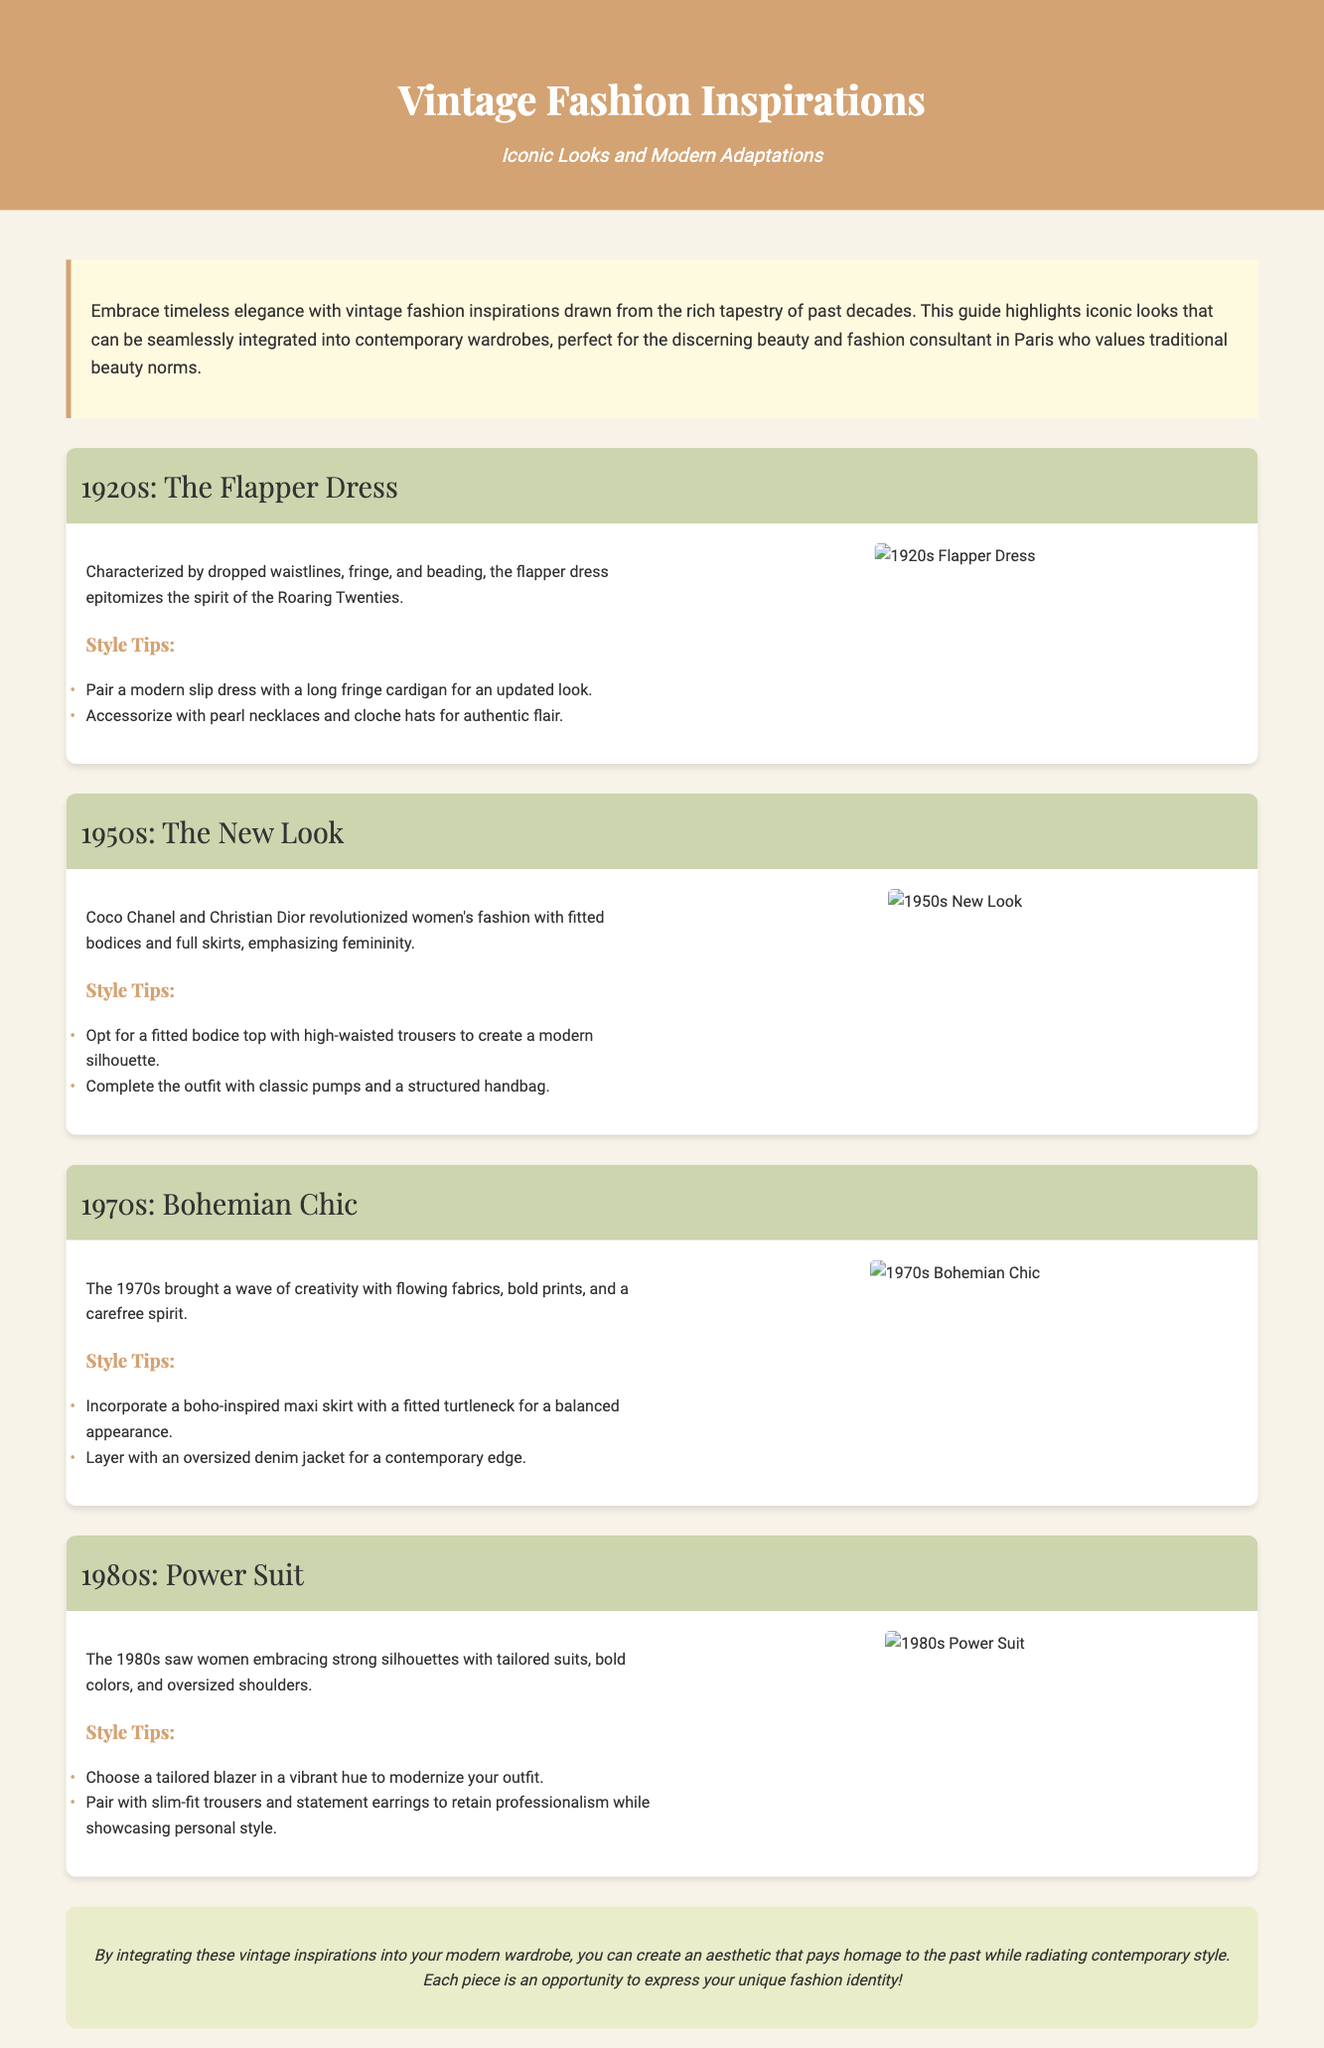What decade is characterized by the Flapper Dress? The document states that the Flapper Dress is an iconic look from the 1920s.
Answer: 1920s What fashion element is typical of the 1950s New Look? The document highlights fitted bodices and full skirts as key elements of the New Look from the 1950s.
Answer: Fitted bodices and full skirts What style tip is recommended for the 1970s Bohemian Chic? One of the style tips for the 1970s suggests incorporating a boho-inspired maxi skirt with a fitted turtleneck.
Answer: Boho-inspired maxi skirt with a fitted turtleneck How should a tailored blazer be styled according to the 1980s section? The document advises pairing a tailored blazer with slim-fit trousers and statement earrings.
Answer: Slim-fit trousers and statement earrings What is the primary focus of the introduction in the document? The introduction emphasizes embracing timeless elegance through vintage fashion inspirations that can be integrated into modern wardrobes.
Answer: Timeless elegance through vintage fashion inspirations Which fashion designer is associated with revolutionizing women's fashion in the 1950s? The document mentions Coco Chanel and Christian Dior in relation to the 1950s fashion revolution.
Answer: Coco Chanel and Christian Dior What color is the background of the header? The document describes the background color of the header as a shade of brown (#d4a373).
Answer: Brown What kind of jacket is suggested for layering in the 1970s section? The document suggests layering with an oversized denim jacket for a contemporary edge.
Answer: Oversized denim jacket 